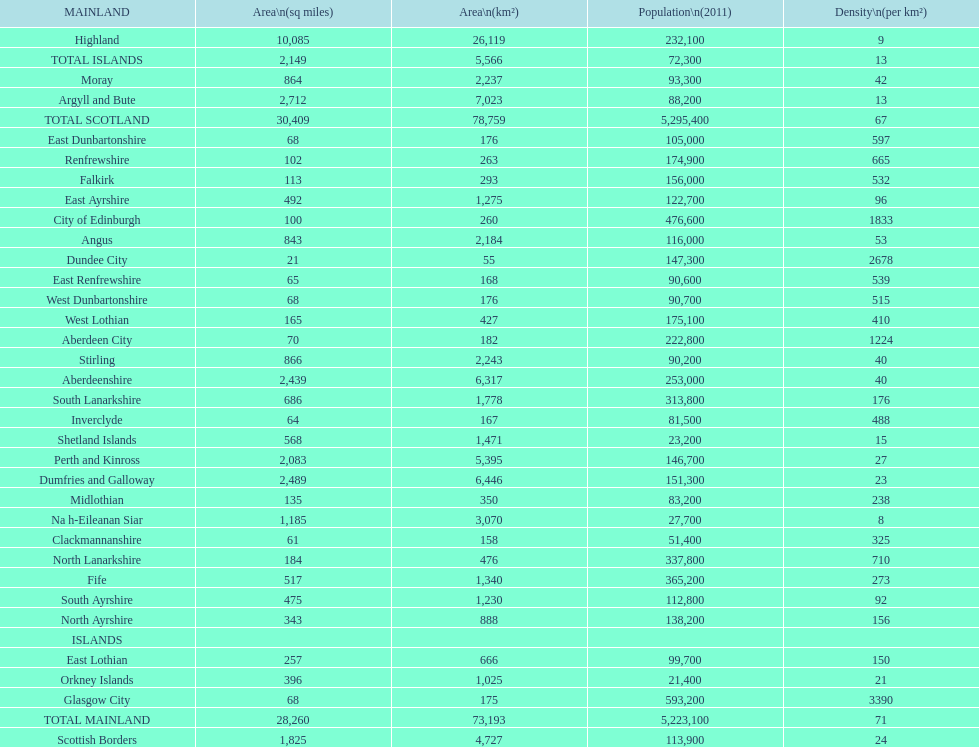What is the difference in square miles from angus and fife? 326. 